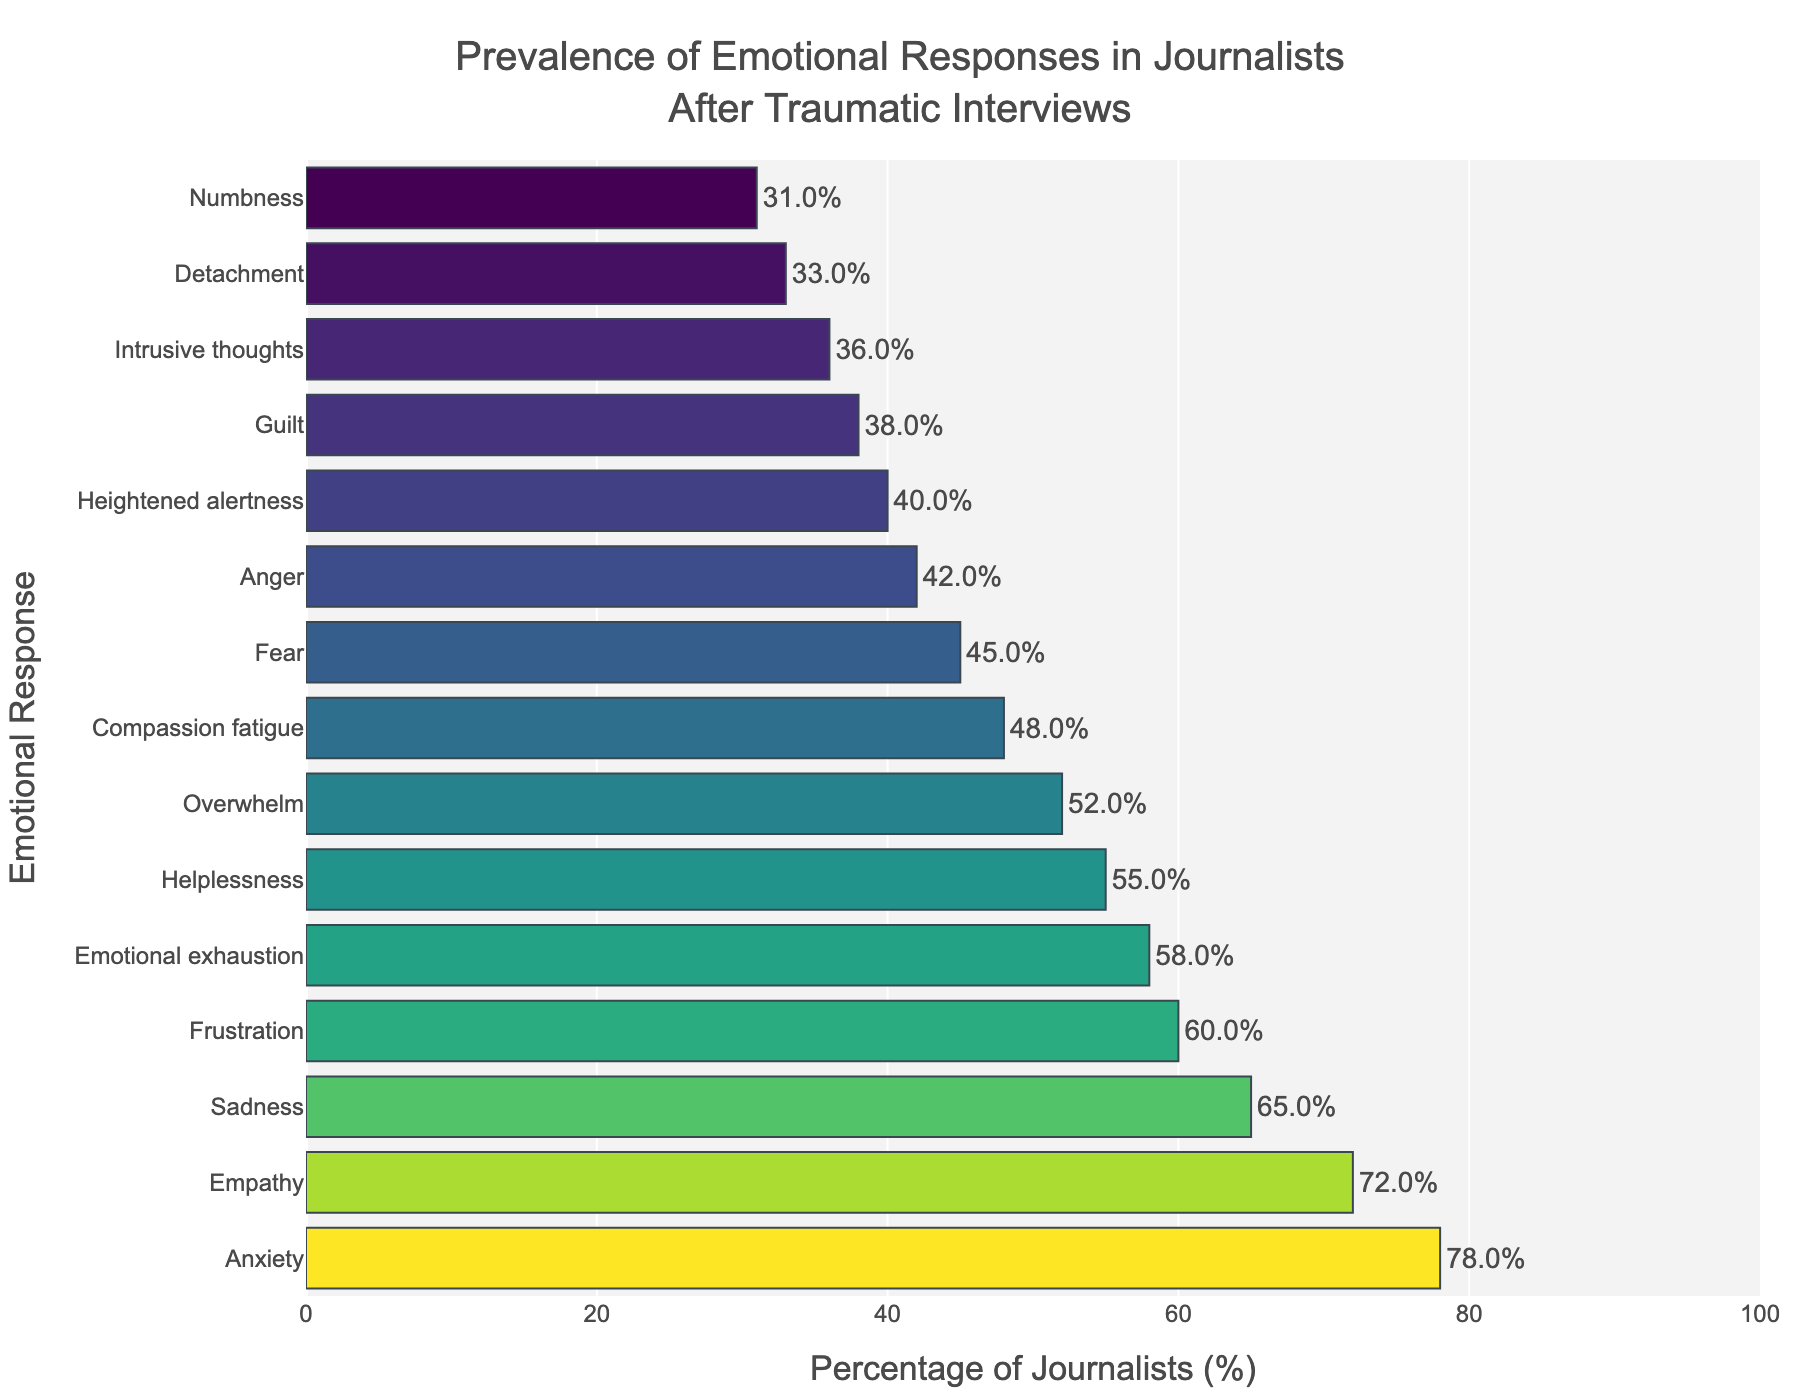Which emotional response has the highest prevalence among journalists after traumatic interviews? By observing the height of the bars in the chart, the bar representing "Anxiety" is the tallest, indicating the highest percentage.
Answer: Anxiety What is the percentage difference between "Anger" and "Sadness"? The percentage for "Sadness" is 65%, and for "Anger" is 42%. The difference is calculated as 65% - 42%.
Answer: 23% Which emotional response has a lower prevalence: "Fear" or "Helplessness"? By comparing the heights of the bars representing "Fear" and "Helplessness", the bar for "Helplessness" (55%) is taller than that of "Fear" (45%). Thus, "Fear" has a lower prevalence.
Answer: Fear What is the sum of percentages for "Empathy", "Compassion fatigue", and "Intrusive thoughts"? Adding the percentages for "Empathy" (72%), "Compassion fatigue" (48%), and "Intrusive thoughts" (36%) equals 72% + 48% + 36%.
Answer: 156% How many emotional responses have a prevalence higher than 50%? By counting the number of bars that extend beyond the 50% mark, we find 7 bars: Anxiety, Sadness, Empathy, Helplessness, Frustration, Overwhelm, and Emotional exhaustion.
Answer: 7 Which two emotional responses have the most similar prevalence? Observing the bar lengths, "Fear" (45%) and "Heightened alertness" (40%) have the closest percentages. Their difference is 5%.
Answer: Fear and Heightened alertness Is the percentage for "Numbness" more or less than half of the percentage for "Anxiety"? The percentage for "Numbness" is 31%, and half of "Anxiety" is 78% / 2 = 39%. Since 31% is less than 39%, "Numbness" is less than half of "Anxiety".
Answer: Less Which emotional responses have a prevalence between 30% and 50%? By examining the bars corresponding to percentages in the range 30% to 50%, they are: Anger (42%), Guilt (38%), Fear (45%), Overwhelm (52%), Compassion fatigue (48%), Intrusive thoughts (36%), Numbness (31%), Heightened alertness (40%), and Detachment (33%).
Answer: Anger, Guilt, Fear, Compassion fatigue, Intrusive thoughts, Numbness, Heightened alertness, Detachment What is the average prevalence of the emotional responses listed? Sum all the percentages: (78 + 65 + 42 + 38 + 55 + 31 + 72 + 45 + 60 + 52 + 48 + 36 + 40 + 58 + 33) and divide by the number of responses (15). The sum is 753, hence the average is 753 / 15.
Answer: 50.2% 